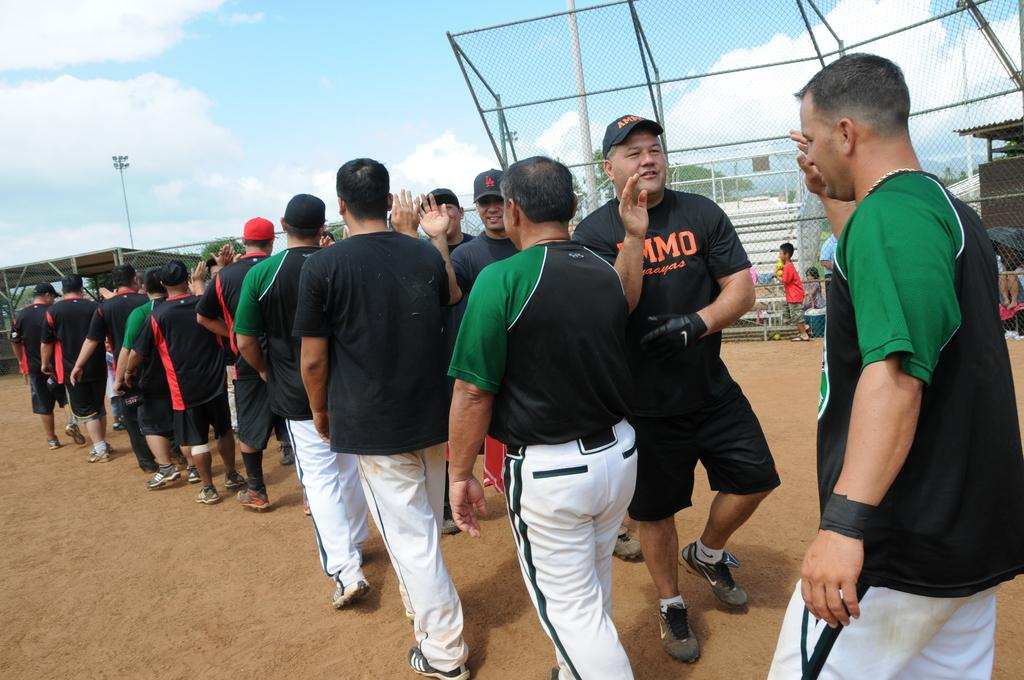<image>
Describe the image concisely. Some baseball players shaking hands, one with a shirt on it that says MMO. 